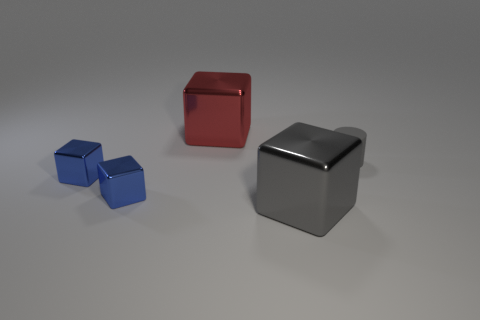Add 5 red metal things. How many objects exist? 10 Subtract all brown blocks. Subtract all brown cylinders. How many blocks are left? 4 Subtract all cylinders. How many objects are left? 4 Add 5 gray cylinders. How many gray cylinders exist? 6 Subtract 2 blue cubes. How many objects are left? 3 Subtract all matte things. Subtract all small blue matte cubes. How many objects are left? 4 Add 4 big shiny cubes. How many big shiny cubes are left? 6 